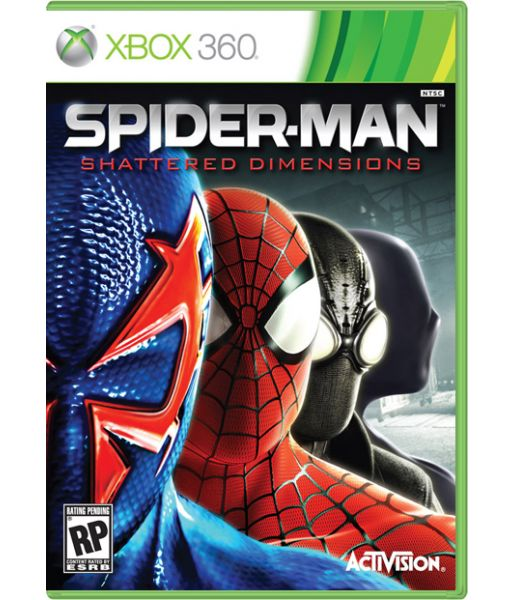Considering the design and theme of the game, what kind of storyline might Spider-Man encounter in 'Shattered Dimensions'? In 'Spider-Man: Shattered Dimensions', the storyline likely revolves around an event that fractures different realities or dimensions, causing chaos that Spider-Man must resolve. Spider-Man might encounter a catastrophic event or villain, such as the breaking of a powerful artifact, which destabilizes the multiverse. The storyline would involve Spider-Man traveling through these fragmented dimensions, each with its own unique version of him and its own set of challenges. He might need to unite these disparate versions of himself to restore balance, facing off against multiple villains from each dimension. The narrative could delve into themes of identity, teamwork, and the nature of heroism as Spider-Man interacts with these alternate versions, learns from their experiences, and solves the overarching crisis threatening the entire multiverse. Imagine a creative twist where Spider-Man encounters an entirely new villain exclusive to each dimension. How would this impact the narrative and player's experience? A creative twist where Spider-Man encounters a unique villain exclusive to each dimension would significantly enhance the narrative and player's experience. These dimension-specific villains could be tailored to the themes and aesthetics of their respective realms, offering players fresh and unique challenges. For instance, a futuristic dimension might feature a tech-savvy supervillain utilizing advanced robotics, while a noir dimension could introduce a shadowy gangster kingpin controlling the criminal underworld. This approach would expand the storyline, giving players rich, episodic narratives where Spider-Man must understand and exploit each villain's weaknesses using dimension-specific abilities. This twist ensures that the gameplay remains compelling and varied, as players navigate through different environments and tackle diverse adversaries, keeping the engagement high and the playthrough experience vastly memorable. If you could add a very unique and wild dimension into 'Shattered Dimensions,' what would it be and how would Spider-Man navigate through it? Imagine adding a dimension set in a surreal, dream-like world where the laws of physics don't apply. In this wild dimension, called the Psychedelic Realm, Spider-Man would navigate through a visually stunning landscape filled with floating islands, shifting colors, and mind-bending architecture. The gameplay mechanics would involve manipulating the environment using Spider-Man's new reality-bending abilities, such as creating platforms out of thin air or altering gravity to swing in impossible directions. Enemies in this realm could be nightmarish creatures that defy conventional forms, requiring creative combat tactics. This dimension would not only offer a visually spectacular experience but also challenge players to think outside the box, solving puzzles and navigating through an ever-changing, kaleidoscopic world. 